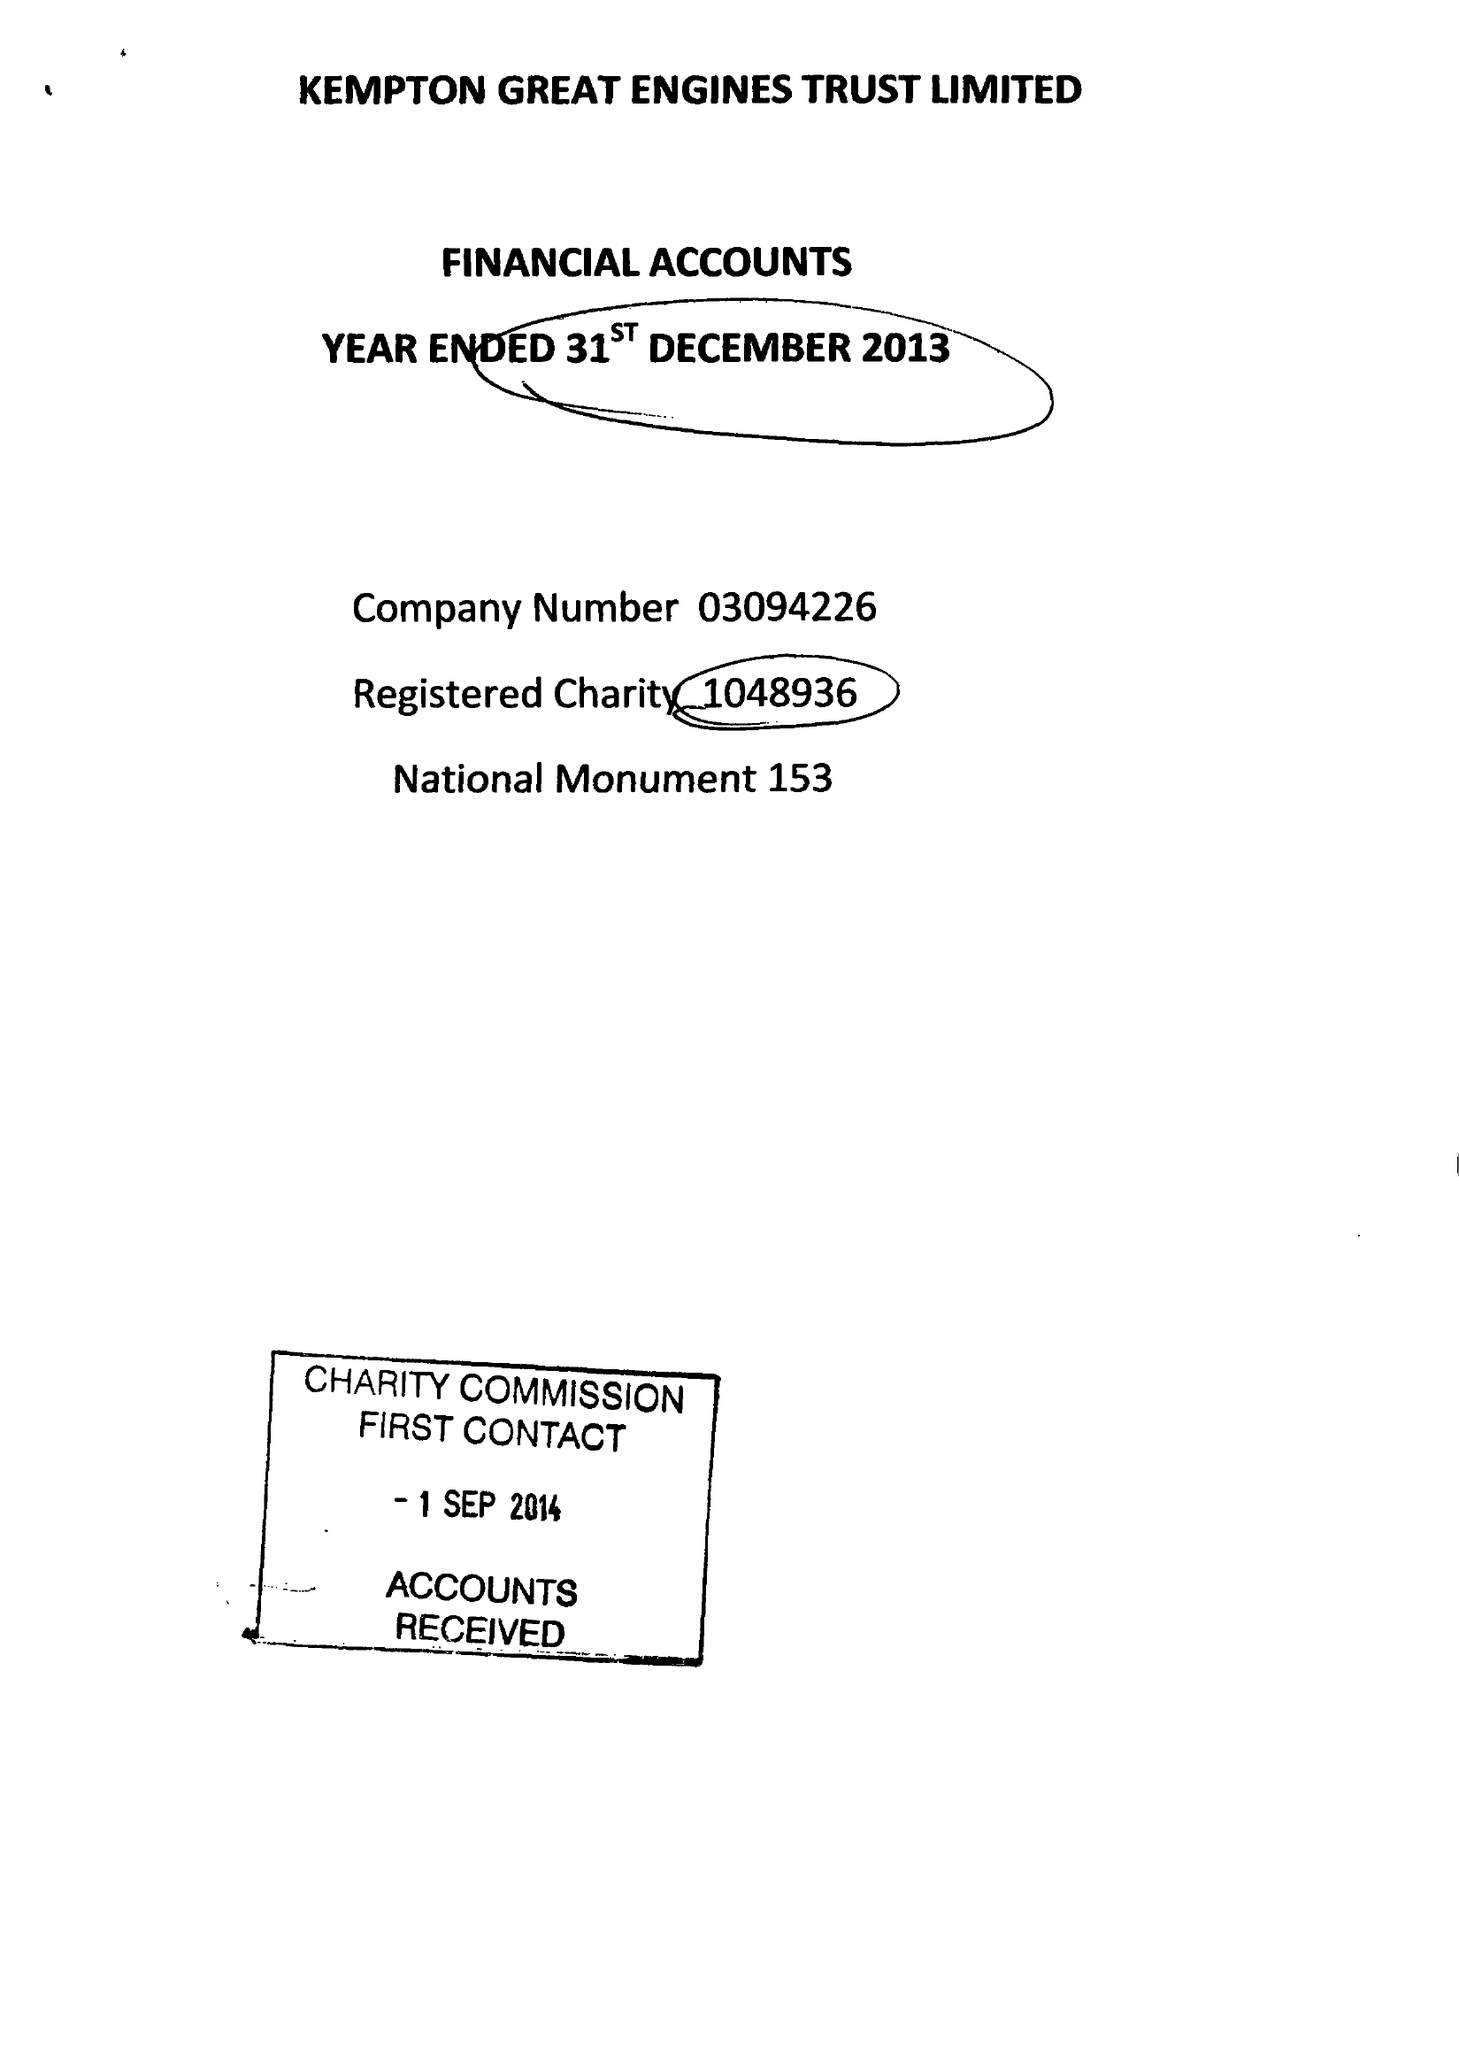What is the value for the income_annually_in_british_pounds?
Answer the question using a single word or phrase. 52517.00 